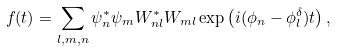Convert formula to latex. <formula><loc_0><loc_0><loc_500><loc_500>f ( t ) = \sum _ { l , m , n } \psi ^ { * } _ { n } \psi _ { m } W ^ { * } _ { n l } W _ { m l } \exp \left ( i ( \phi _ { n } - \phi ^ { \delta } _ { l } ) t \right ) ,</formula> 